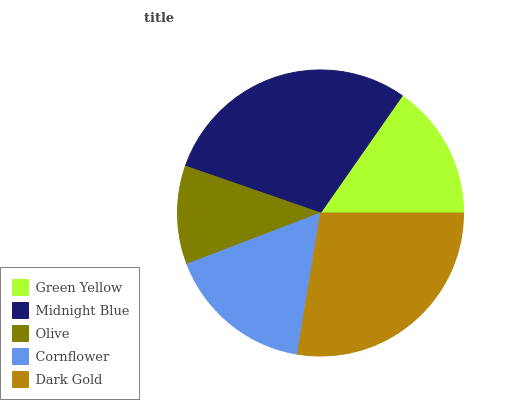Is Olive the minimum?
Answer yes or no. Yes. Is Midnight Blue the maximum?
Answer yes or no. Yes. Is Midnight Blue the minimum?
Answer yes or no. No. Is Olive the maximum?
Answer yes or no. No. Is Midnight Blue greater than Olive?
Answer yes or no. Yes. Is Olive less than Midnight Blue?
Answer yes or no. Yes. Is Olive greater than Midnight Blue?
Answer yes or no. No. Is Midnight Blue less than Olive?
Answer yes or no. No. Is Cornflower the high median?
Answer yes or no. Yes. Is Cornflower the low median?
Answer yes or no. Yes. Is Green Yellow the high median?
Answer yes or no. No. Is Midnight Blue the low median?
Answer yes or no. No. 